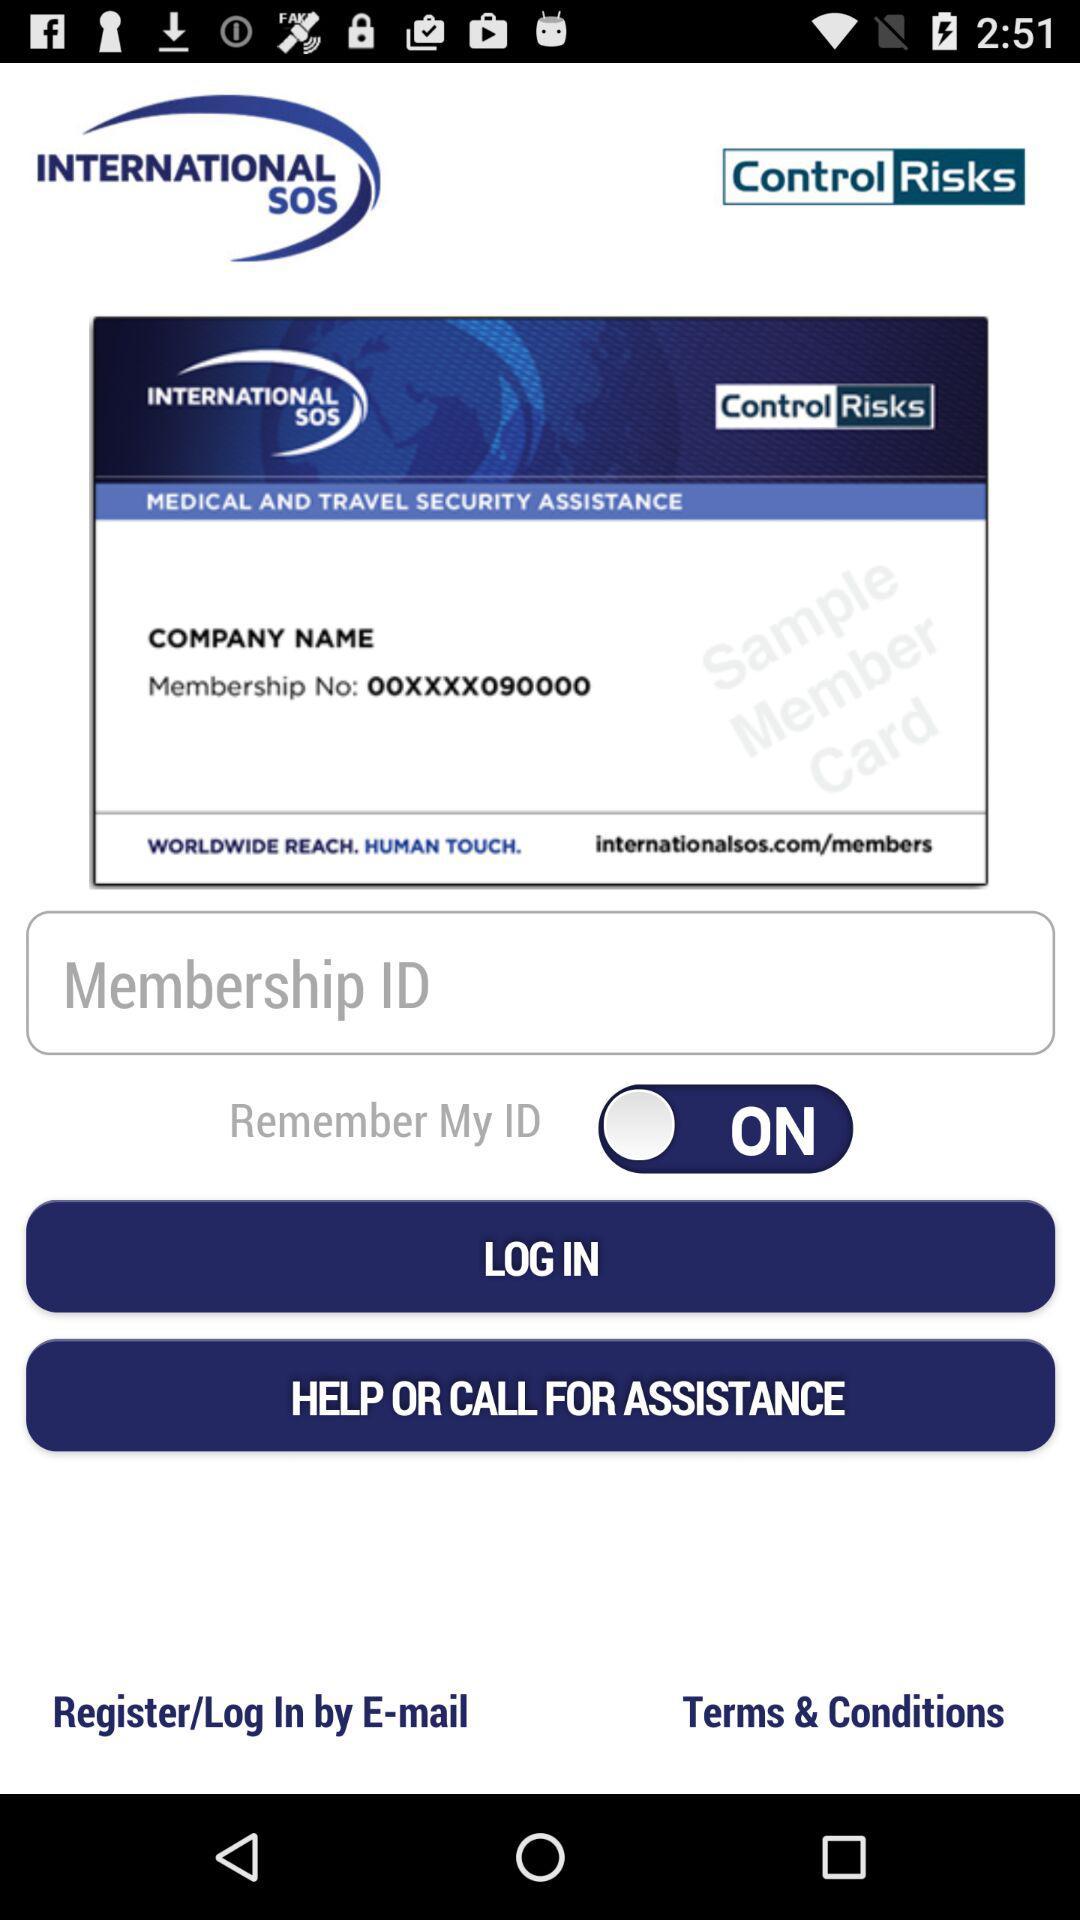What is the membership number? The membership number is 00XXXX090000. 